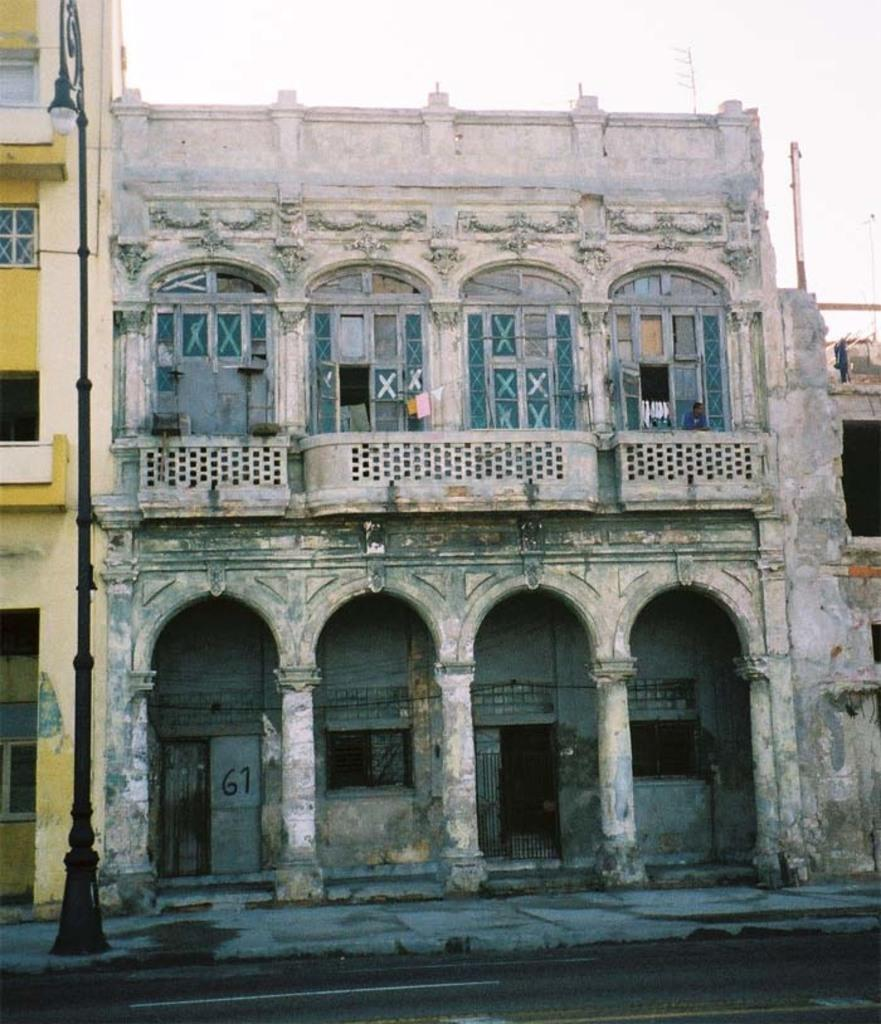How many buildings can be seen in the image? There are two buildings in the image. What is visible at the top of the image? The sky is visible at the top of the image. What type of wool is being spun by the wheel in the image? There is no wheel or wool present in the image; it only features two buildings and the sky. 